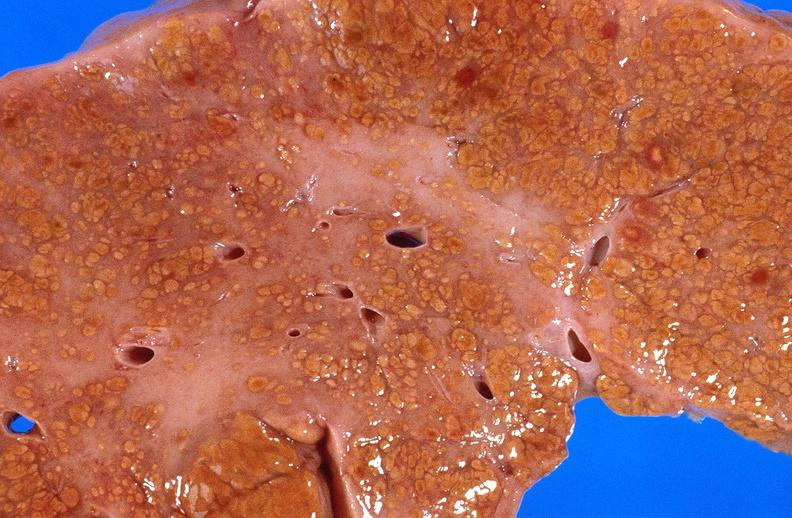does this partially fixed gross show cirrhosis?
Answer the question using a single word or phrase. No 